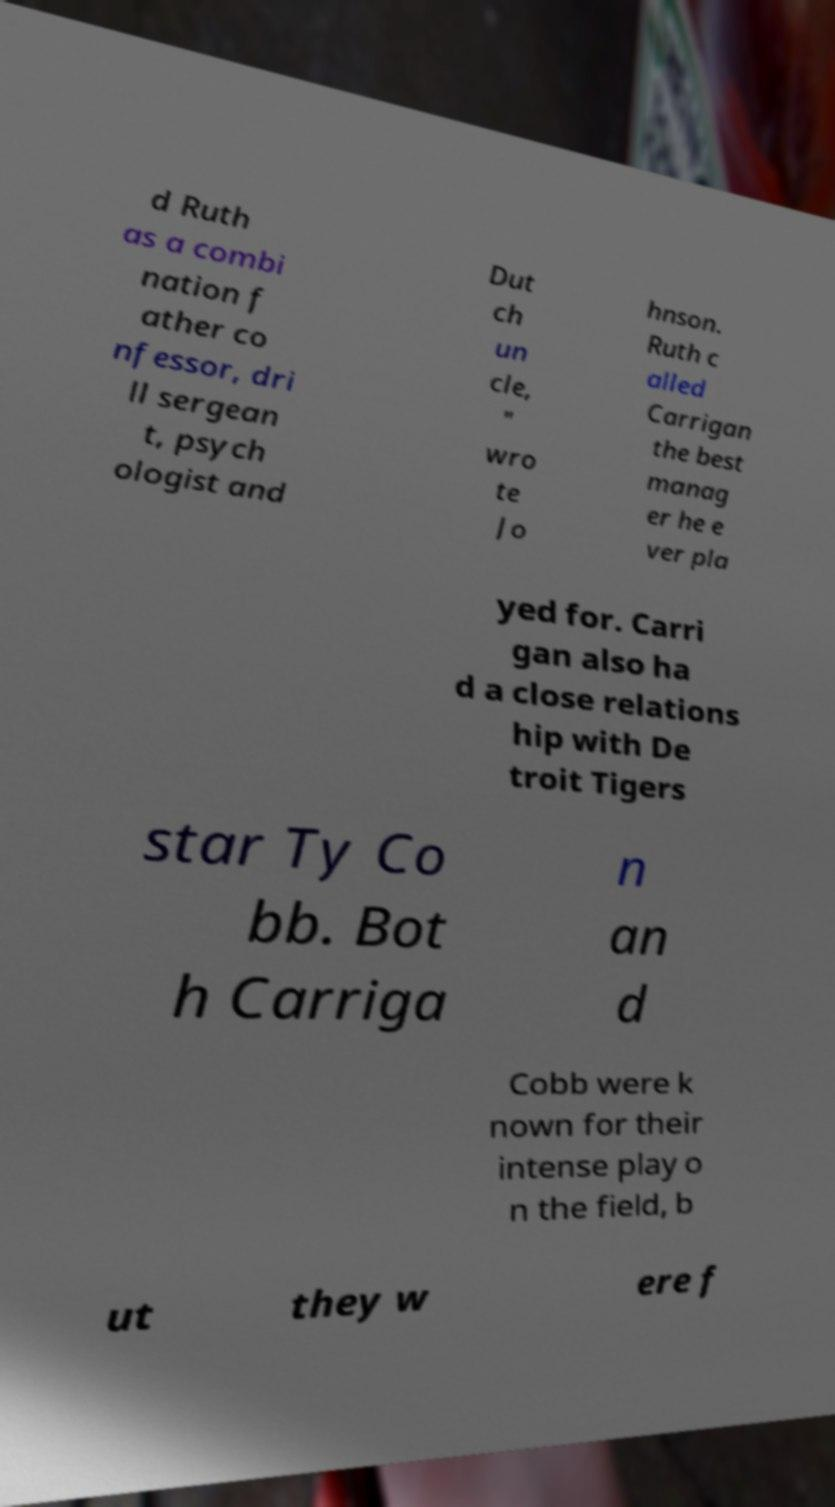I need the written content from this picture converted into text. Can you do that? d Ruth as a combi nation f ather co nfessor, dri ll sergean t, psych ologist and Dut ch un cle, " wro te Jo hnson. Ruth c alled Carrigan the best manag er he e ver pla yed for. Carri gan also ha d a close relations hip with De troit Tigers star Ty Co bb. Bot h Carriga n an d Cobb were k nown for their intense play o n the field, b ut they w ere f 